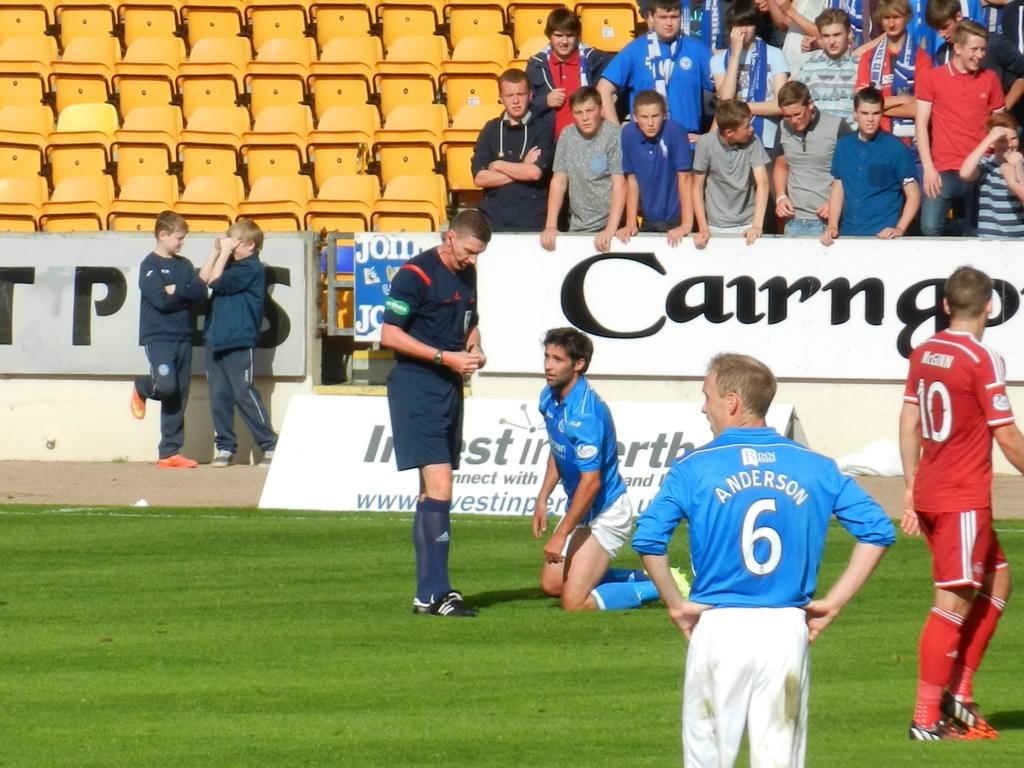What is the player in red's number?
Offer a terse response. 10. 